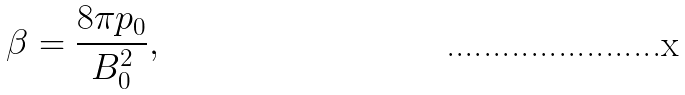Convert formula to latex. <formula><loc_0><loc_0><loc_500><loc_500>\beta = \frac { 8 \pi p _ { 0 } } { B _ { 0 } ^ { 2 } } ,</formula> 